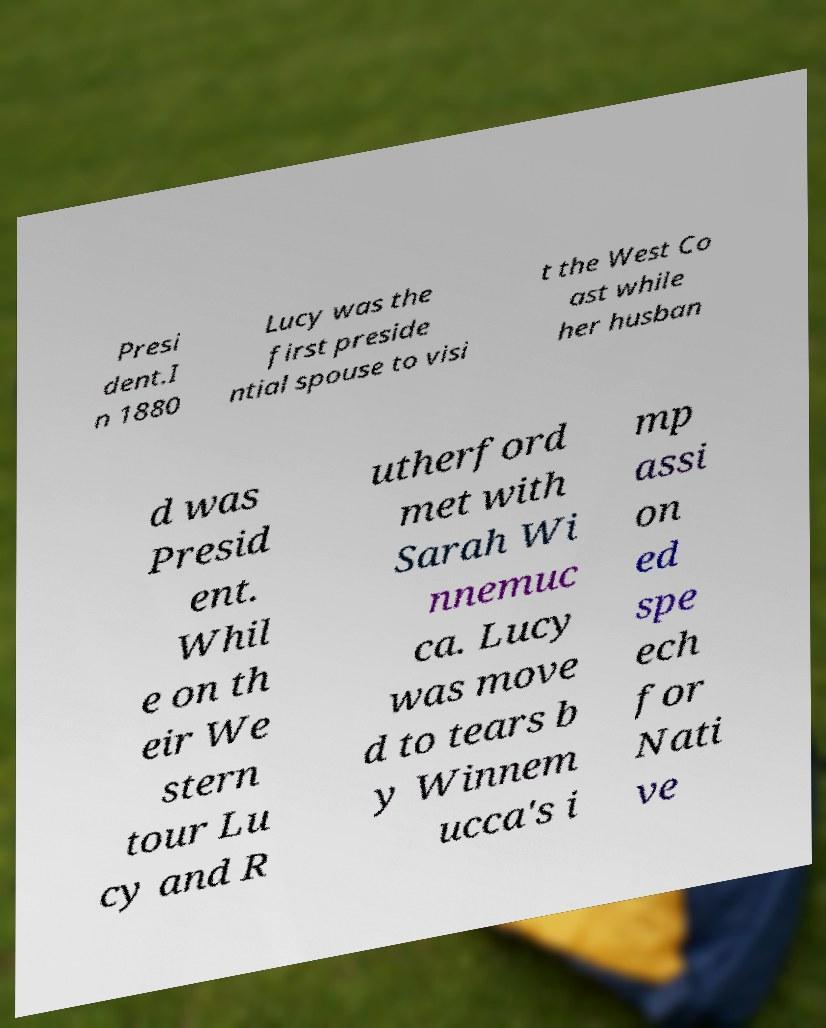Could you extract and type out the text from this image? Presi dent.I n 1880 Lucy was the first preside ntial spouse to visi t the West Co ast while her husban d was Presid ent. Whil e on th eir We stern tour Lu cy and R utherford met with Sarah Wi nnemuc ca. Lucy was move d to tears b y Winnem ucca's i mp assi on ed spe ech for Nati ve 